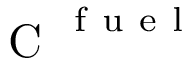<formula> <loc_0><loc_0><loc_500><loc_500>C ^ { f u e l }</formula> 